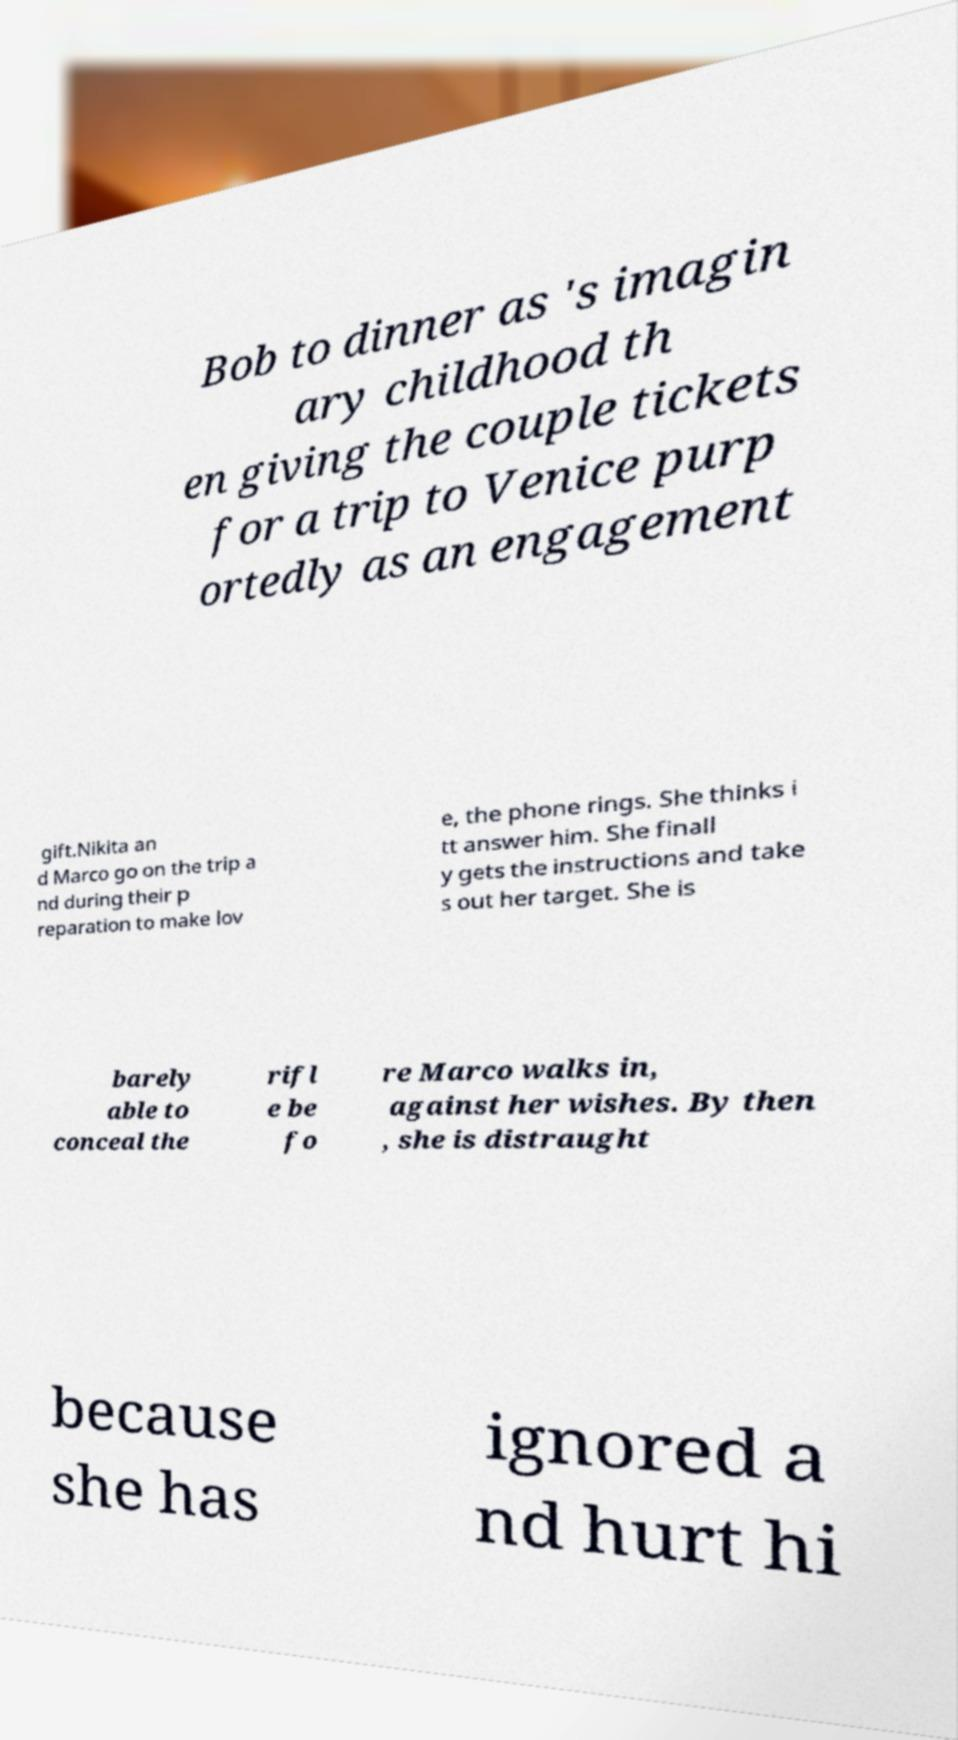Could you assist in decoding the text presented in this image and type it out clearly? Bob to dinner as 's imagin ary childhood th en giving the couple tickets for a trip to Venice purp ortedly as an engagement gift.Nikita an d Marco go on the trip a nd during their p reparation to make lov e, the phone rings. She thinks i tt answer him. She finall y gets the instructions and take s out her target. She is barely able to conceal the rifl e be fo re Marco walks in, against her wishes. By then , she is distraught because she has ignored a nd hurt hi 